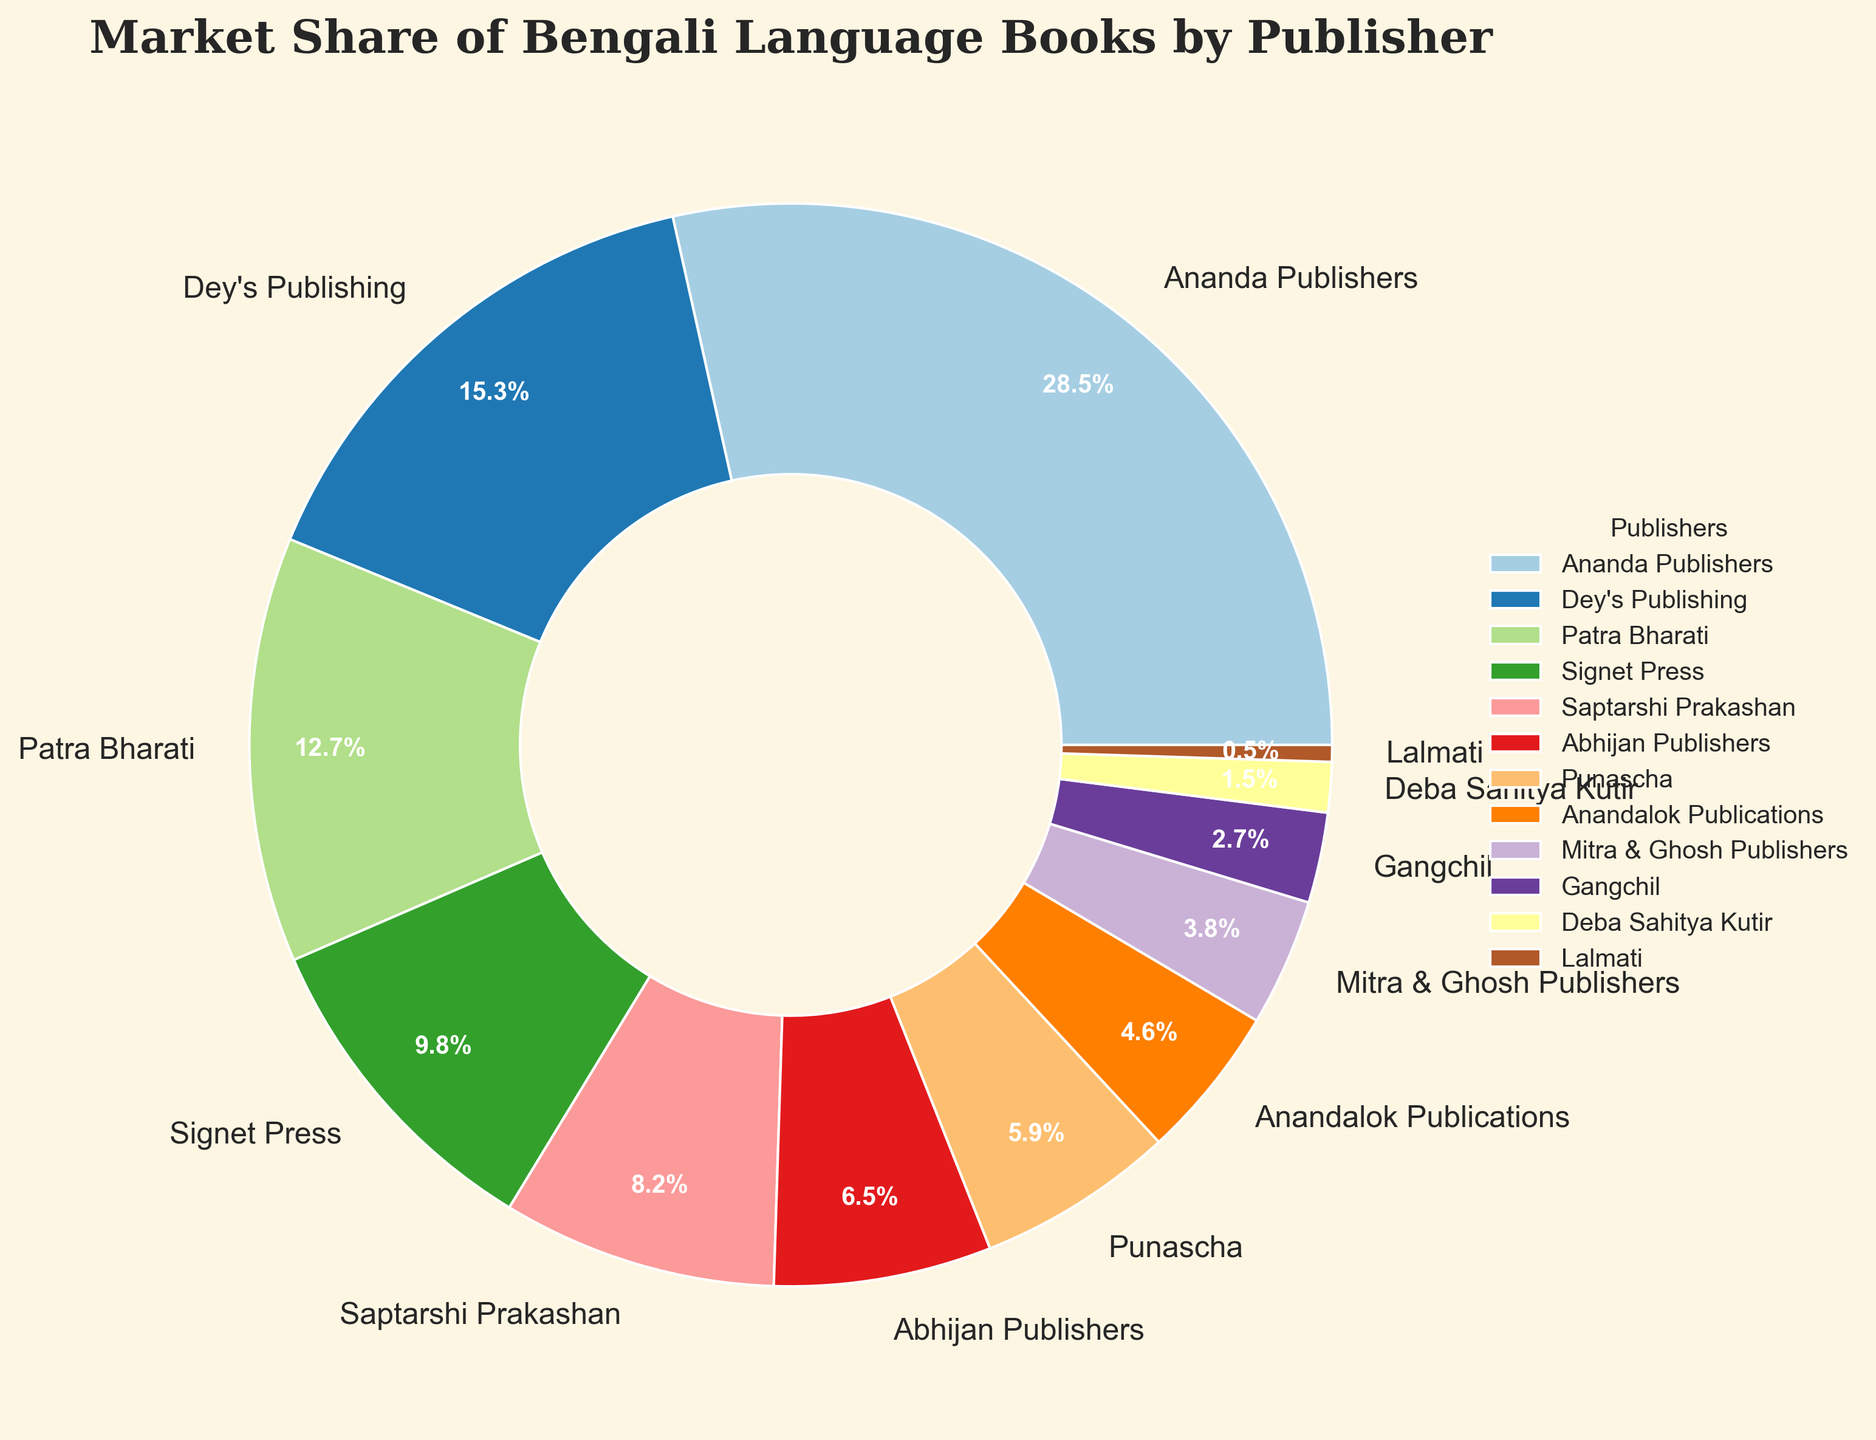Which publisher has the highest market share? The highest market share can be identified by looking at the largest pie slice. This slice belongs to Ananda Publishers, which has a 28.5% share.
Answer: Ananda Publishers Which two publishers have market shares closest to 10%? By comparing the percentages for each publisher shown on the pie chart, the closest to 10% are Signet Press (9.8%) and Saptarshi Prakashan (8.2%).
Answer: Signet Press and Saptarshi Prakashan What is the combined market share of Dey's Publishing and Patra Bharati? To find the combined market share, sum the percentages of Dey's Publishing (15.3%) and Patra Bharati (12.7%): 15.3 + 12.7 = 28.
Answer: 28% How does the market share of Mitra & Ghosh Publishers compare to that of Deba Sahitya Kutir? The market share of Mitra & Ghosh Publishers (3.8%) is greater than that of Deba Sahitya Kutir (1.5%).
Answer: Greater What is the difference in market share between the publisher with the highest share and the publisher with the lowest share? The highest market share is Ananda Publishers with 28.5%, and the lowest is Lalmati with 0.5%. The difference is 28.5 - 0.5 = 28.
Answer: 28% How many publishers have a market share greater than 5%? By counting the slices labeled with percentages greater than 5% on the pie chart, we find that there are seven publishers exceeding 5%.
Answer: 7 Which publisher's market share is represented by the smallest slice? The smallest slice of the pie chart corresponds to Lalmati, which has a market share of 0.5%.
Answer: Lalmati What is the total market share represented by publishers with a share below 10%? Summing up the market shares of Signet Press (9.8%), Saptarshi Prakashan (8.2%), Abhijan Publishers (6.5%), Punascha (5.9%), Anandalok Publications (4.6%), Mitra & Ghosh Publishers (3.8%), Gangchil (2.7%), Deba Sahitya Kutir (1.5%), and Lalmati (0.5%): 9.8 + 8.2 + 6.5 + 5.9 + 4.6 + 3.8 + 2.7 + 1.5 + 0.5 = 43.5%.
Answer: 43.5% Which three publishers together have approximately half of the market share? The sum of the market shares of Ananda Publishers (28.5%), Dey's Publishing (15.3%), and Patra Bharati (12.7%) is approximately half of the total: 28.5 + 15.3 + 12.7 = 56.5%.
Answer: Ananda Publishers, Dey's Publishing, Patra Bharati 